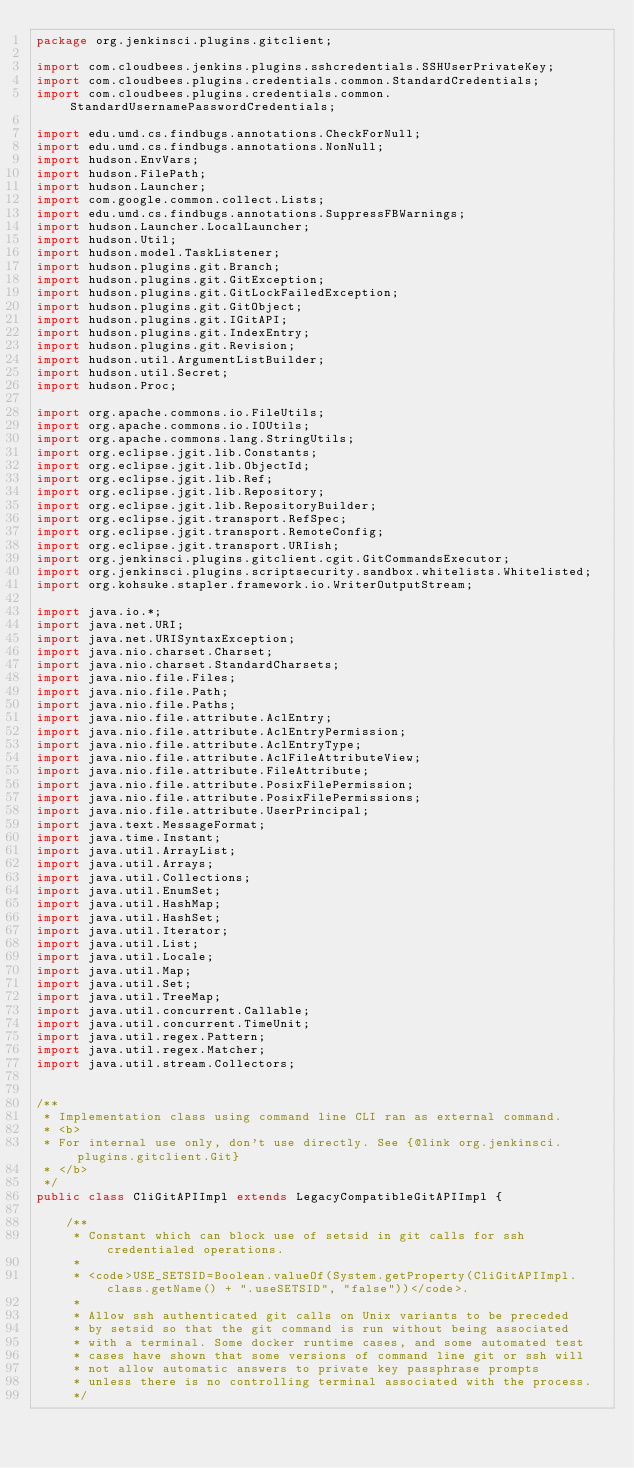Convert code to text. <code><loc_0><loc_0><loc_500><loc_500><_Java_>package org.jenkinsci.plugins.gitclient;

import com.cloudbees.jenkins.plugins.sshcredentials.SSHUserPrivateKey;
import com.cloudbees.plugins.credentials.common.StandardCredentials;
import com.cloudbees.plugins.credentials.common.StandardUsernamePasswordCredentials;

import edu.umd.cs.findbugs.annotations.CheckForNull;
import edu.umd.cs.findbugs.annotations.NonNull;
import hudson.EnvVars;
import hudson.FilePath;
import hudson.Launcher;
import com.google.common.collect.Lists;
import edu.umd.cs.findbugs.annotations.SuppressFBWarnings;
import hudson.Launcher.LocalLauncher;
import hudson.Util;
import hudson.model.TaskListener;
import hudson.plugins.git.Branch;
import hudson.plugins.git.GitException;
import hudson.plugins.git.GitLockFailedException;
import hudson.plugins.git.GitObject;
import hudson.plugins.git.IGitAPI;
import hudson.plugins.git.IndexEntry;
import hudson.plugins.git.Revision;
import hudson.util.ArgumentListBuilder;
import hudson.util.Secret;
import hudson.Proc;

import org.apache.commons.io.FileUtils;
import org.apache.commons.io.IOUtils;
import org.apache.commons.lang.StringUtils;
import org.eclipse.jgit.lib.Constants;
import org.eclipse.jgit.lib.ObjectId;
import org.eclipse.jgit.lib.Ref;
import org.eclipse.jgit.lib.Repository;
import org.eclipse.jgit.lib.RepositoryBuilder;
import org.eclipse.jgit.transport.RefSpec;
import org.eclipse.jgit.transport.RemoteConfig;
import org.eclipse.jgit.transport.URIish;
import org.jenkinsci.plugins.gitclient.cgit.GitCommandsExecutor;
import org.jenkinsci.plugins.scriptsecurity.sandbox.whitelists.Whitelisted;
import org.kohsuke.stapler.framework.io.WriterOutputStream;

import java.io.*;
import java.net.URI;
import java.net.URISyntaxException;
import java.nio.charset.Charset;
import java.nio.charset.StandardCharsets;
import java.nio.file.Files;
import java.nio.file.Path;
import java.nio.file.Paths;
import java.nio.file.attribute.AclEntry;
import java.nio.file.attribute.AclEntryPermission;
import java.nio.file.attribute.AclEntryType;
import java.nio.file.attribute.AclFileAttributeView;
import java.nio.file.attribute.FileAttribute;
import java.nio.file.attribute.PosixFilePermission;
import java.nio.file.attribute.PosixFilePermissions;
import java.nio.file.attribute.UserPrincipal;
import java.text.MessageFormat;
import java.time.Instant;
import java.util.ArrayList;
import java.util.Arrays;
import java.util.Collections;
import java.util.EnumSet;
import java.util.HashMap;
import java.util.HashSet;
import java.util.Iterator;
import java.util.List;
import java.util.Locale;
import java.util.Map;
import java.util.Set;
import java.util.TreeMap;
import java.util.concurrent.Callable;
import java.util.concurrent.TimeUnit;
import java.util.regex.Pattern;
import java.util.regex.Matcher;
import java.util.stream.Collectors;


/**
 * Implementation class using command line CLI ran as external command.
 * <b>
 * For internal use only, don't use directly. See {@link org.jenkinsci.plugins.gitclient.Git}
 * </b>
 */
public class CliGitAPIImpl extends LegacyCompatibleGitAPIImpl {

    /**
     * Constant which can block use of setsid in git calls for ssh credentialed operations.
     *
     * <code>USE_SETSID=Boolean.valueOf(System.getProperty(CliGitAPIImpl.class.getName() + ".useSETSID", "false"))</code>.
     *
     * Allow ssh authenticated git calls on Unix variants to be preceded
     * by setsid so that the git command is run without being associated
     * with a terminal. Some docker runtime cases, and some automated test
     * cases have shown that some versions of command line git or ssh will
     * not allow automatic answers to private key passphrase prompts
     * unless there is no controlling terminal associated with the process.
     */</code> 